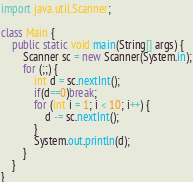Convert code to text. <code><loc_0><loc_0><loc_500><loc_500><_Java_>import java.util.Scanner;

class Main {
    public static void main(String[] args) {
        Scanner sc = new Scanner(System.in);
        for (;;) {
            int d = sc.nextInt();
            if(d==0)break;
            for (int i = 1; i < 10; i++) {
                d -= sc.nextInt();
            }
            System.out.println(d);
        }
    }
}
</code> 